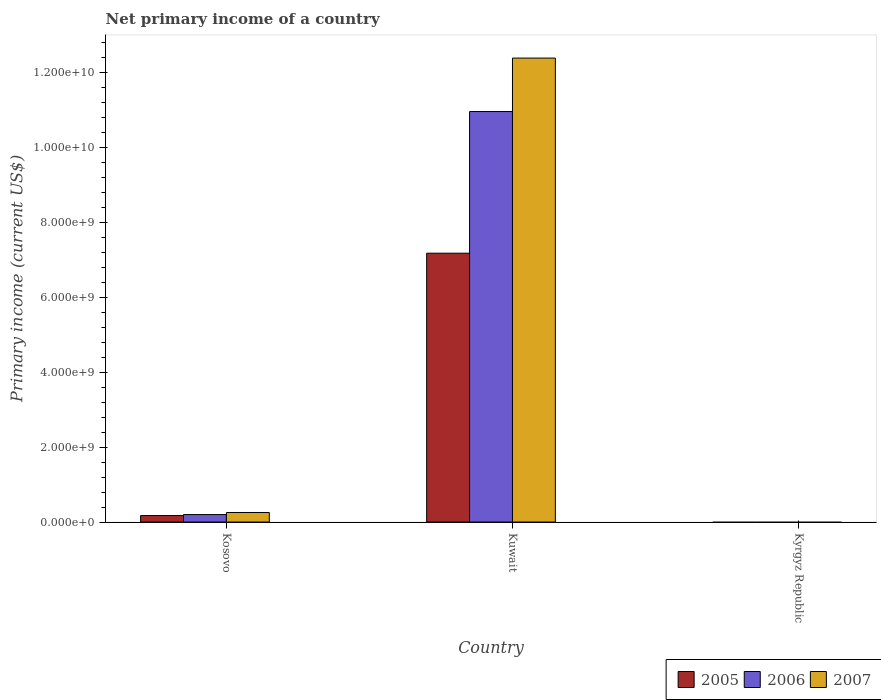How many different coloured bars are there?
Give a very brief answer. 3. What is the label of the 2nd group of bars from the left?
Make the answer very short. Kuwait. Across all countries, what is the maximum primary income in 2007?
Offer a terse response. 1.24e+1. Across all countries, what is the minimum primary income in 2007?
Offer a terse response. 0. In which country was the primary income in 2005 maximum?
Offer a very short reply. Kuwait. What is the total primary income in 2006 in the graph?
Your answer should be very brief. 1.12e+1. What is the difference between the primary income in 2007 in Kosovo and that in Kuwait?
Make the answer very short. -1.21e+1. What is the difference between the primary income in 2007 in Kosovo and the primary income in 2006 in Kuwait?
Your response must be concise. -1.07e+1. What is the average primary income in 2006 per country?
Your answer should be very brief. 3.72e+09. What is the difference between the primary income of/in 2005 and primary income of/in 2006 in Kosovo?
Offer a very short reply. -2.62e+07. In how many countries, is the primary income in 2005 greater than 5600000000 US$?
Ensure brevity in your answer.  1. What is the ratio of the primary income in 2005 in Kosovo to that in Kuwait?
Your answer should be very brief. 0.02. Is the primary income in 2007 in Kosovo less than that in Kuwait?
Keep it short and to the point. Yes. Is the difference between the primary income in 2005 in Kosovo and Kuwait greater than the difference between the primary income in 2006 in Kosovo and Kuwait?
Make the answer very short. Yes. What is the difference between the highest and the lowest primary income in 2005?
Ensure brevity in your answer.  7.18e+09. Is it the case that in every country, the sum of the primary income in 2005 and primary income in 2006 is greater than the primary income in 2007?
Your answer should be compact. No. How many countries are there in the graph?
Make the answer very short. 3. Does the graph contain grids?
Ensure brevity in your answer.  No. What is the title of the graph?
Offer a terse response. Net primary income of a country. Does "1993" appear as one of the legend labels in the graph?
Your response must be concise. No. What is the label or title of the X-axis?
Ensure brevity in your answer.  Country. What is the label or title of the Y-axis?
Your answer should be very brief. Primary income (current US$). What is the Primary income (current US$) in 2005 in Kosovo?
Provide a succinct answer. 1.73e+08. What is the Primary income (current US$) in 2006 in Kosovo?
Provide a short and direct response. 1.99e+08. What is the Primary income (current US$) in 2007 in Kosovo?
Provide a short and direct response. 2.55e+08. What is the Primary income (current US$) of 2005 in Kuwait?
Offer a terse response. 7.18e+09. What is the Primary income (current US$) in 2006 in Kuwait?
Your response must be concise. 1.10e+1. What is the Primary income (current US$) in 2007 in Kuwait?
Provide a short and direct response. 1.24e+1. What is the Primary income (current US$) in 2005 in Kyrgyz Republic?
Ensure brevity in your answer.  0. What is the Primary income (current US$) of 2007 in Kyrgyz Republic?
Give a very brief answer. 0. Across all countries, what is the maximum Primary income (current US$) in 2005?
Provide a short and direct response. 7.18e+09. Across all countries, what is the maximum Primary income (current US$) of 2006?
Provide a short and direct response. 1.10e+1. Across all countries, what is the maximum Primary income (current US$) of 2007?
Your answer should be compact. 1.24e+1. Across all countries, what is the minimum Primary income (current US$) of 2005?
Provide a succinct answer. 0. Across all countries, what is the minimum Primary income (current US$) in 2006?
Provide a short and direct response. 0. What is the total Primary income (current US$) of 2005 in the graph?
Your answer should be very brief. 7.35e+09. What is the total Primary income (current US$) of 2006 in the graph?
Offer a very short reply. 1.12e+1. What is the total Primary income (current US$) in 2007 in the graph?
Ensure brevity in your answer.  1.26e+1. What is the difference between the Primary income (current US$) of 2005 in Kosovo and that in Kuwait?
Offer a terse response. -7.01e+09. What is the difference between the Primary income (current US$) in 2006 in Kosovo and that in Kuwait?
Your answer should be compact. -1.08e+1. What is the difference between the Primary income (current US$) of 2007 in Kosovo and that in Kuwait?
Ensure brevity in your answer.  -1.21e+1. What is the difference between the Primary income (current US$) in 2005 in Kosovo and the Primary income (current US$) in 2006 in Kuwait?
Provide a short and direct response. -1.08e+1. What is the difference between the Primary income (current US$) in 2005 in Kosovo and the Primary income (current US$) in 2007 in Kuwait?
Your response must be concise. -1.22e+1. What is the difference between the Primary income (current US$) in 2006 in Kosovo and the Primary income (current US$) in 2007 in Kuwait?
Provide a succinct answer. -1.22e+1. What is the average Primary income (current US$) of 2005 per country?
Ensure brevity in your answer.  2.45e+09. What is the average Primary income (current US$) of 2006 per country?
Give a very brief answer. 3.72e+09. What is the average Primary income (current US$) of 2007 per country?
Provide a succinct answer. 4.22e+09. What is the difference between the Primary income (current US$) of 2005 and Primary income (current US$) of 2006 in Kosovo?
Your answer should be compact. -2.62e+07. What is the difference between the Primary income (current US$) of 2005 and Primary income (current US$) of 2007 in Kosovo?
Give a very brief answer. -8.20e+07. What is the difference between the Primary income (current US$) of 2006 and Primary income (current US$) of 2007 in Kosovo?
Offer a terse response. -5.57e+07. What is the difference between the Primary income (current US$) of 2005 and Primary income (current US$) of 2006 in Kuwait?
Your response must be concise. -3.78e+09. What is the difference between the Primary income (current US$) in 2005 and Primary income (current US$) in 2007 in Kuwait?
Your answer should be compact. -5.21e+09. What is the difference between the Primary income (current US$) of 2006 and Primary income (current US$) of 2007 in Kuwait?
Your response must be concise. -1.43e+09. What is the ratio of the Primary income (current US$) in 2005 in Kosovo to that in Kuwait?
Keep it short and to the point. 0.02. What is the ratio of the Primary income (current US$) of 2006 in Kosovo to that in Kuwait?
Provide a short and direct response. 0.02. What is the ratio of the Primary income (current US$) of 2007 in Kosovo to that in Kuwait?
Offer a terse response. 0.02. What is the difference between the highest and the lowest Primary income (current US$) in 2005?
Your answer should be very brief. 7.18e+09. What is the difference between the highest and the lowest Primary income (current US$) in 2006?
Offer a terse response. 1.10e+1. What is the difference between the highest and the lowest Primary income (current US$) in 2007?
Provide a succinct answer. 1.24e+1. 